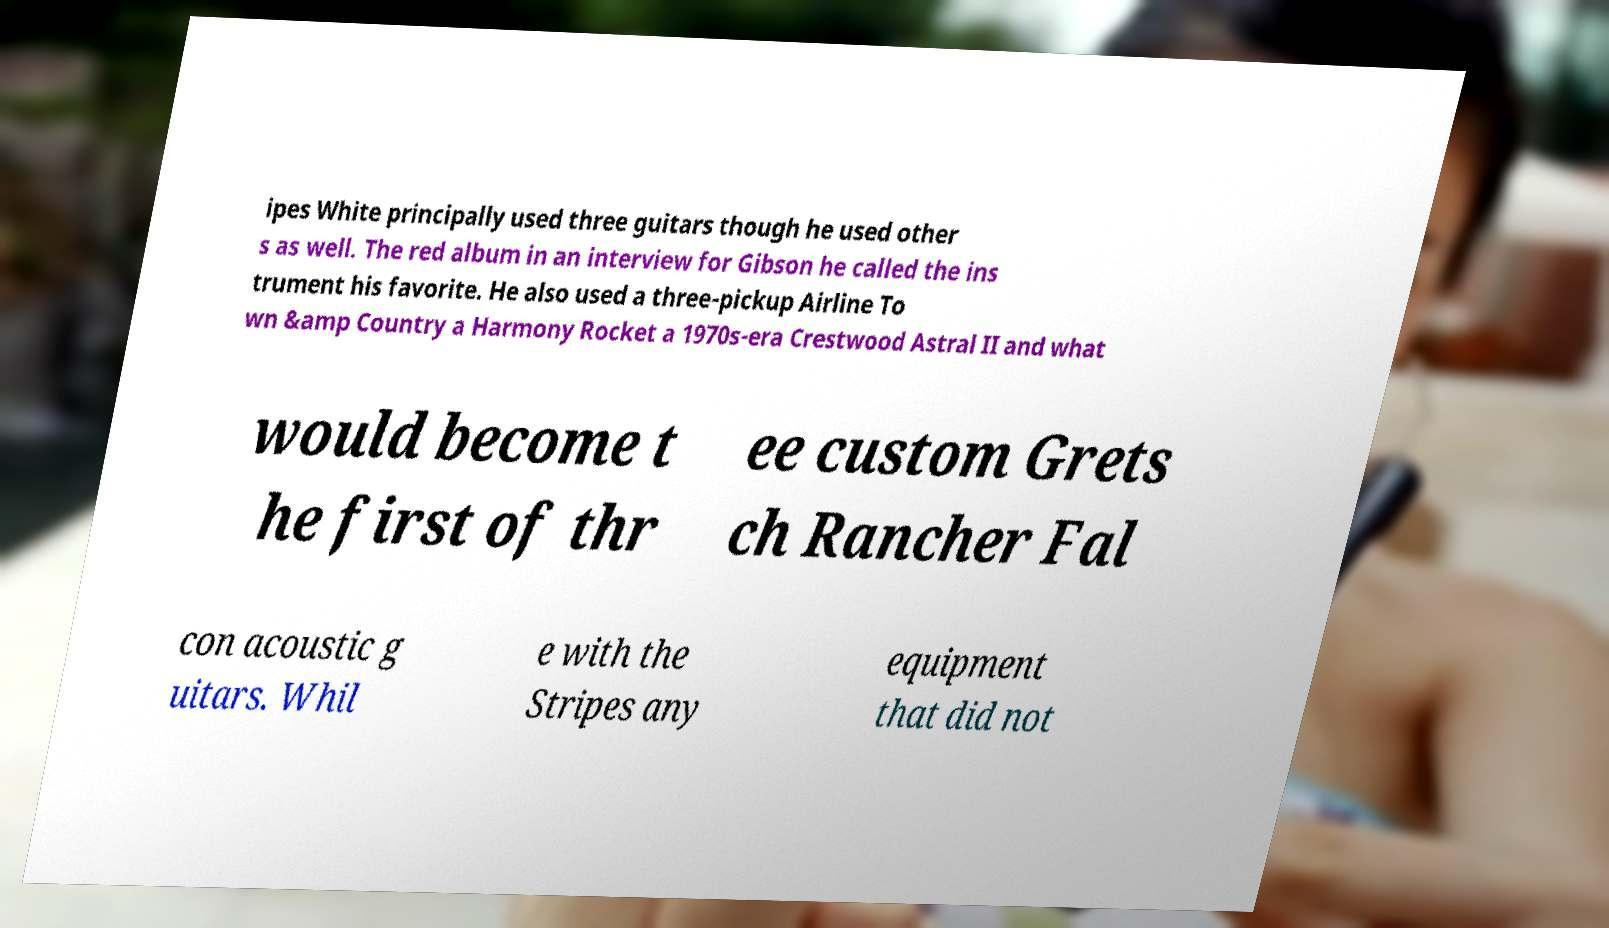Please identify and transcribe the text found in this image. ipes White principally used three guitars though he used other s as well. The red album in an interview for Gibson he called the ins trument his favorite. He also used a three-pickup Airline To wn &amp Country a Harmony Rocket a 1970s-era Crestwood Astral II and what would become t he first of thr ee custom Grets ch Rancher Fal con acoustic g uitars. Whil e with the Stripes any equipment that did not 